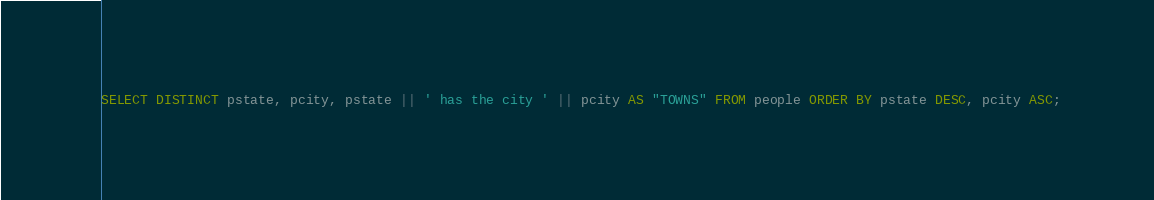Convert code to text. <code><loc_0><loc_0><loc_500><loc_500><_SQL_>SELECT DISTINCT pstate, pcity, pstate || ' has the city ' || pcity AS "TOWNS" FROM people ORDER BY pstate DESC, pcity ASC;</code> 